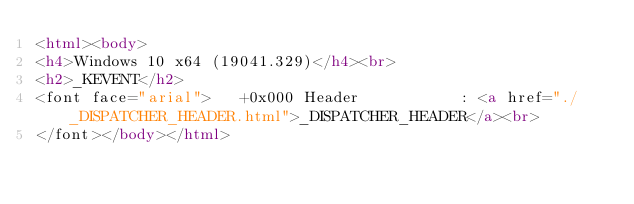<code> <loc_0><loc_0><loc_500><loc_500><_HTML_><html><body>
<h4>Windows 10 x64 (19041.329)</h4><br>
<h2>_KEVENT</h2>
<font face="arial">   +0x000 Header           : <a href="./_DISPATCHER_HEADER.html">_DISPATCHER_HEADER</a><br>
</font></body></html></code> 